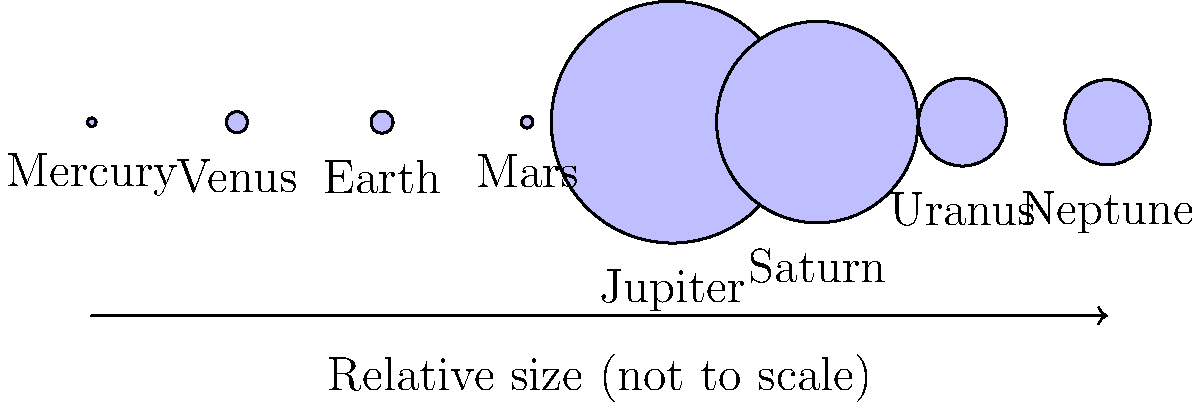In the diagram above, the planets of our solar system are represented by scaled circles. Which planet is represented by the largest circle, and approximately how many times larger is its diameter compared to Earth's? To answer this question, we need to follow these steps:

1. Identify the largest circle in the diagram:
   The largest circle represents Jupiter.

2. Compare Jupiter's diameter to Earth's:
   - Jupiter's diameter: 139,820 km
   - Earth's diameter: 12,742 km

3. Calculate the ratio:
   $\frac{\text{Jupiter's diameter}}{\text{Earth's diameter}} = \frac{139,820}{12,742} \approx 10.97$

4. Round the result to the nearest whole number:
   10.97 rounds to 11

Therefore, Jupiter's diameter is approximately 11 times larger than Earth's.

This comparison illustrates the vast size difference between the gas giant Jupiter and our home planet, Earth, which is crucial for understanding the scale and diversity of planets in our solar system.
Answer: Jupiter, 11 times 